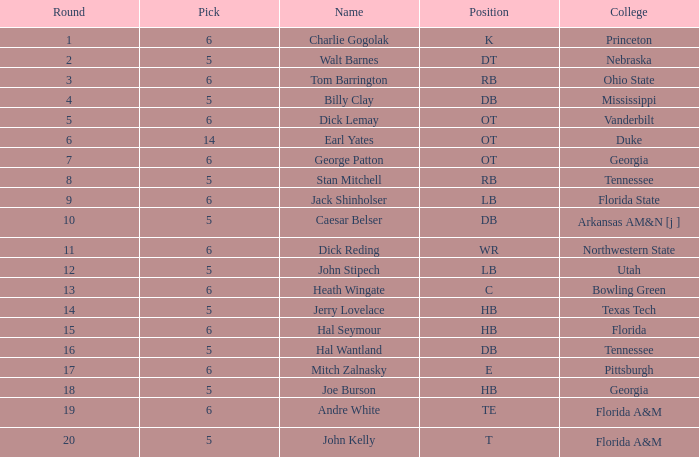What is Pick, when Round is 15? 6.0. 